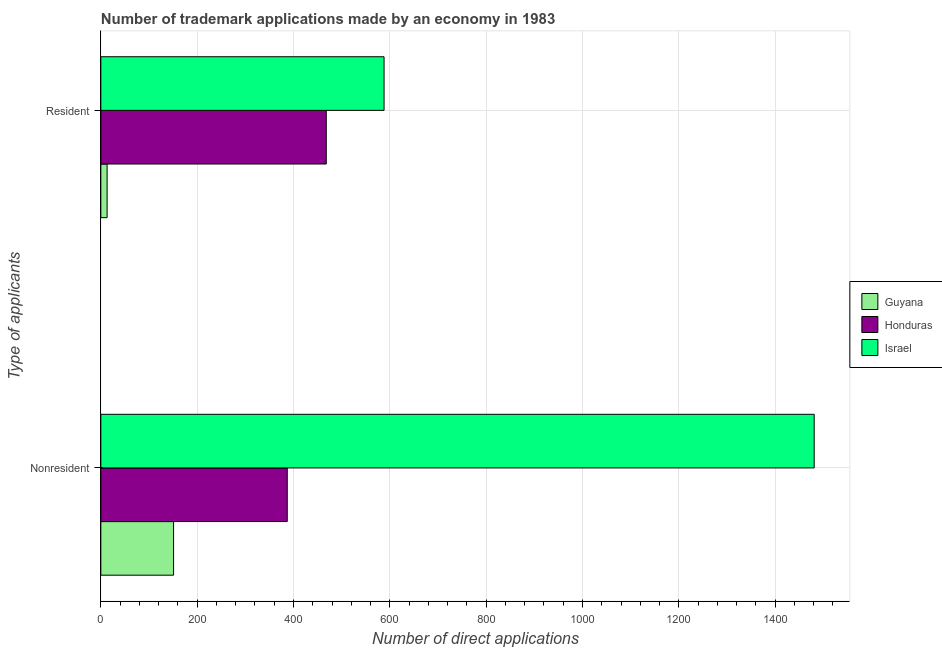Are the number of bars on each tick of the Y-axis equal?
Provide a succinct answer. Yes. How many bars are there on the 1st tick from the top?
Offer a terse response. 3. How many bars are there on the 1st tick from the bottom?
Your answer should be compact. 3. What is the label of the 1st group of bars from the top?
Keep it short and to the point. Resident. What is the number of trademark applications made by residents in Honduras?
Offer a very short reply. 468. Across all countries, what is the maximum number of trademark applications made by residents?
Your response must be concise. 588. Across all countries, what is the minimum number of trademark applications made by non residents?
Your response must be concise. 151. In which country was the number of trademark applications made by non residents maximum?
Your answer should be compact. Israel. In which country was the number of trademark applications made by non residents minimum?
Your answer should be compact. Guyana. What is the total number of trademark applications made by residents in the graph?
Provide a succinct answer. 1069. What is the difference between the number of trademark applications made by non residents in Israel and that in Honduras?
Your answer should be compact. 1094. What is the difference between the number of trademark applications made by residents in Honduras and the number of trademark applications made by non residents in Guyana?
Offer a very short reply. 317. What is the average number of trademark applications made by residents per country?
Offer a terse response. 356.33. What is the difference between the number of trademark applications made by non residents and number of trademark applications made by residents in Israel?
Your response must be concise. 893. In how many countries, is the number of trademark applications made by non residents greater than 120 ?
Make the answer very short. 3. What is the ratio of the number of trademark applications made by residents in Honduras to that in Guyana?
Your response must be concise. 36. What does the 2nd bar from the top in Nonresident represents?
Offer a terse response. Honduras. What does the 1st bar from the bottom in Resident represents?
Keep it short and to the point. Guyana. How many bars are there?
Give a very brief answer. 6. Are all the bars in the graph horizontal?
Keep it short and to the point. Yes. How many countries are there in the graph?
Ensure brevity in your answer.  3. What is the difference between two consecutive major ticks on the X-axis?
Offer a very short reply. 200. Are the values on the major ticks of X-axis written in scientific E-notation?
Your answer should be compact. No. How many legend labels are there?
Ensure brevity in your answer.  3. What is the title of the graph?
Keep it short and to the point. Number of trademark applications made by an economy in 1983. What is the label or title of the X-axis?
Provide a succinct answer. Number of direct applications. What is the label or title of the Y-axis?
Your response must be concise. Type of applicants. What is the Number of direct applications in Guyana in Nonresident?
Give a very brief answer. 151. What is the Number of direct applications in Honduras in Nonresident?
Offer a terse response. 387. What is the Number of direct applications of Israel in Nonresident?
Your answer should be very brief. 1481. What is the Number of direct applications of Guyana in Resident?
Provide a short and direct response. 13. What is the Number of direct applications of Honduras in Resident?
Provide a short and direct response. 468. What is the Number of direct applications of Israel in Resident?
Provide a succinct answer. 588. Across all Type of applicants, what is the maximum Number of direct applications of Guyana?
Offer a very short reply. 151. Across all Type of applicants, what is the maximum Number of direct applications in Honduras?
Offer a very short reply. 468. Across all Type of applicants, what is the maximum Number of direct applications in Israel?
Offer a very short reply. 1481. Across all Type of applicants, what is the minimum Number of direct applications of Guyana?
Your answer should be very brief. 13. Across all Type of applicants, what is the minimum Number of direct applications of Honduras?
Your answer should be very brief. 387. Across all Type of applicants, what is the minimum Number of direct applications of Israel?
Provide a short and direct response. 588. What is the total Number of direct applications of Guyana in the graph?
Your answer should be compact. 164. What is the total Number of direct applications of Honduras in the graph?
Provide a succinct answer. 855. What is the total Number of direct applications of Israel in the graph?
Make the answer very short. 2069. What is the difference between the Number of direct applications in Guyana in Nonresident and that in Resident?
Your response must be concise. 138. What is the difference between the Number of direct applications of Honduras in Nonresident and that in Resident?
Keep it short and to the point. -81. What is the difference between the Number of direct applications of Israel in Nonresident and that in Resident?
Offer a very short reply. 893. What is the difference between the Number of direct applications of Guyana in Nonresident and the Number of direct applications of Honduras in Resident?
Offer a terse response. -317. What is the difference between the Number of direct applications of Guyana in Nonresident and the Number of direct applications of Israel in Resident?
Your answer should be very brief. -437. What is the difference between the Number of direct applications in Honduras in Nonresident and the Number of direct applications in Israel in Resident?
Make the answer very short. -201. What is the average Number of direct applications of Honduras per Type of applicants?
Keep it short and to the point. 427.5. What is the average Number of direct applications in Israel per Type of applicants?
Provide a succinct answer. 1034.5. What is the difference between the Number of direct applications of Guyana and Number of direct applications of Honduras in Nonresident?
Make the answer very short. -236. What is the difference between the Number of direct applications of Guyana and Number of direct applications of Israel in Nonresident?
Make the answer very short. -1330. What is the difference between the Number of direct applications in Honduras and Number of direct applications in Israel in Nonresident?
Offer a very short reply. -1094. What is the difference between the Number of direct applications of Guyana and Number of direct applications of Honduras in Resident?
Keep it short and to the point. -455. What is the difference between the Number of direct applications in Guyana and Number of direct applications in Israel in Resident?
Provide a short and direct response. -575. What is the difference between the Number of direct applications of Honduras and Number of direct applications of Israel in Resident?
Ensure brevity in your answer.  -120. What is the ratio of the Number of direct applications in Guyana in Nonresident to that in Resident?
Your answer should be very brief. 11.62. What is the ratio of the Number of direct applications in Honduras in Nonresident to that in Resident?
Ensure brevity in your answer.  0.83. What is the ratio of the Number of direct applications of Israel in Nonresident to that in Resident?
Offer a very short reply. 2.52. What is the difference between the highest and the second highest Number of direct applications in Guyana?
Offer a terse response. 138. What is the difference between the highest and the second highest Number of direct applications of Israel?
Ensure brevity in your answer.  893. What is the difference between the highest and the lowest Number of direct applications in Guyana?
Your response must be concise. 138. What is the difference between the highest and the lowest Number of direct applications of Israel?
Ensure brevity in your answer.  893. 